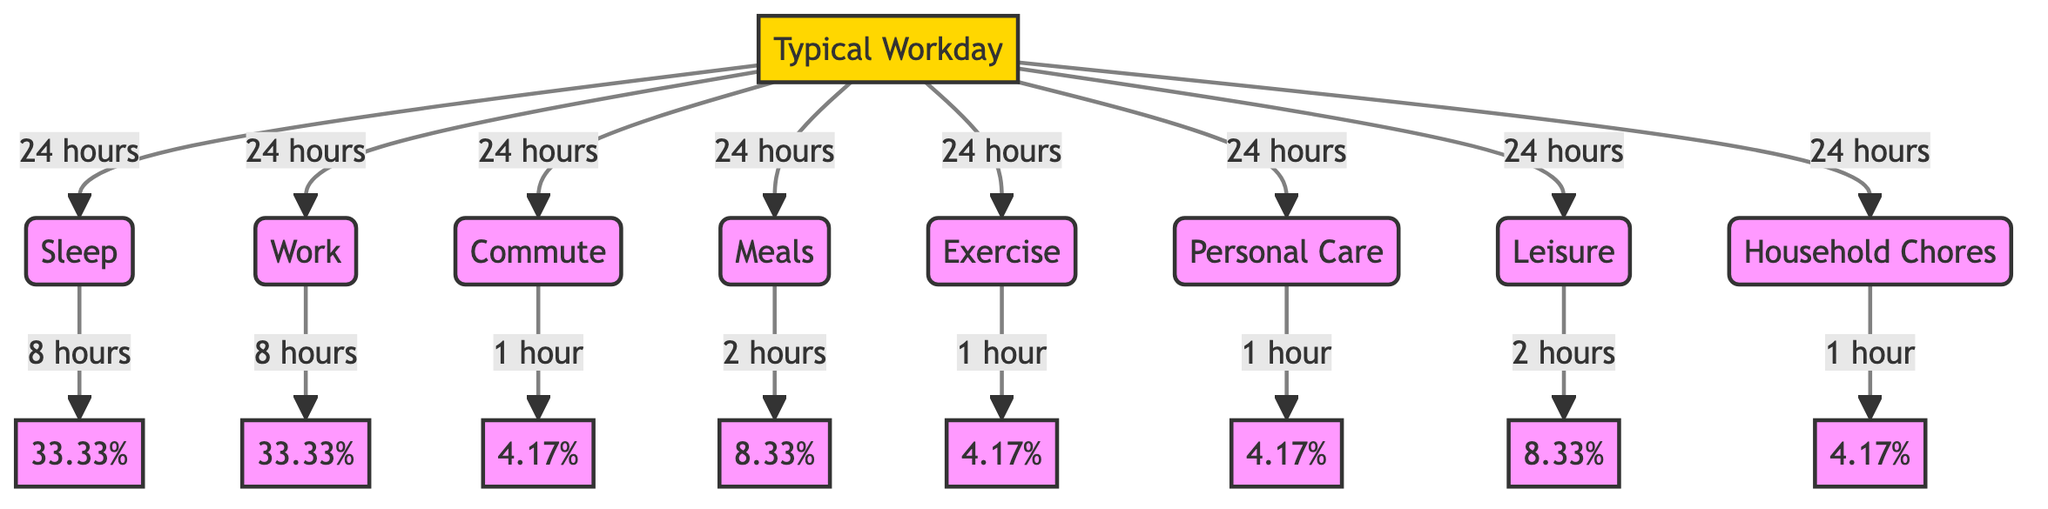What is the total duration of sleep in hours? The diagram indicates that the total duration of sleep is specified as 8 hours within the "Sleep" node.
Answer: 8 hours How much time is allocated to work? The diagram shows that the "Work" node has a duration of 8 hours associated with it.
Answer: 8 hours What percentage of the workday is dedicated to meals? The "Meals" node shows a duration of 2 hours. This is calculated as (2 hours / 24 hours) * 100 = 8.33%.
Answer: 8.33% How many hours are spent on personal care? The diagram specifies that the "Personal Care" node has a duration of 1 hour.
Answer: 1 hour What is the total duration for leisure and household chores combined? The "Leisure" node has 2 hours, and the "Household Chores" node has 1 hour. Adding these, 2 hours + 1 hour = 3 hours in total.
Answer: 3 hours Which activity has the longest duration and how long is it? Both "Sleep" and "Work" nodes each have a duration of 8 hours. These are the longest durations in the diagram.
Answer: 8 hours How many total activities are represented in the diagram? There are eight main activities: Sleep, Work, Commute, Meals, Exercise, Personal Care, Leisure, and Household Chores. Count these nodes leads to a total of 8.
Answer: 8 How long is the total commuting time? The "Commute" node states the duration is 1 hour for travel related to the workplace.
Answer: 1 hour What percentage of the day is spent on exercise? The "Exercise" node specifies a duration of 1 hour. The percent can be calculated as (1 hour / 24 hours) * 100 = 4.17%.
Answer: 4.17% 